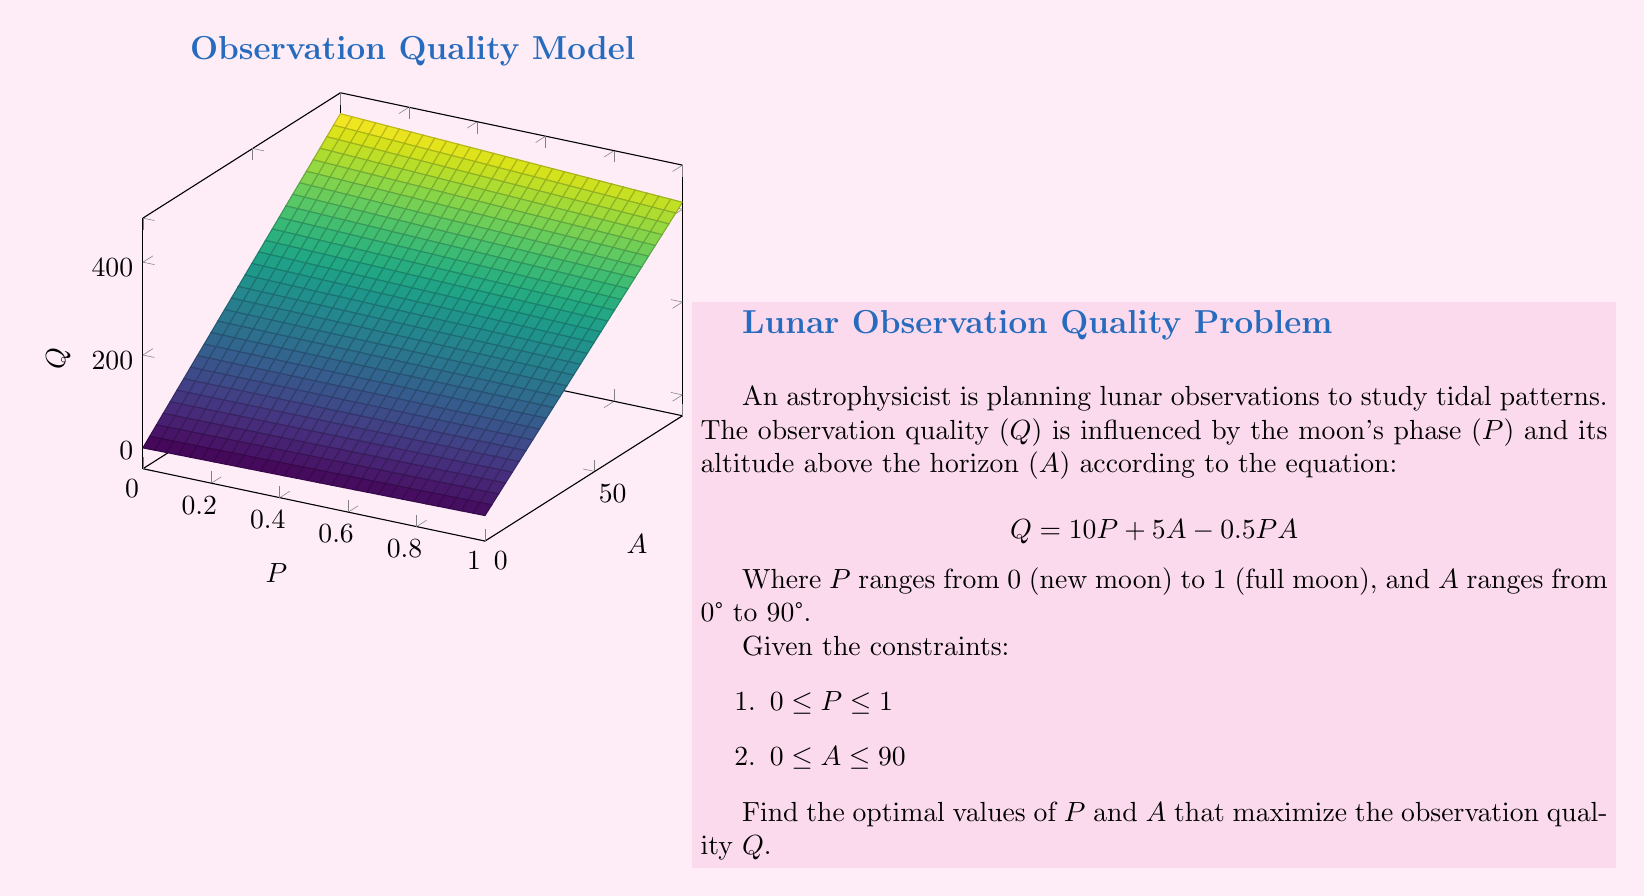Teach me how to tackle this problem. To find the optimal values of P and A that maximize Q, we need to use techniques from multivariable calculus:

1. Calculate partial derivatives:
   $\frac{\partial Q}{\partial P} = 10 - 0.5A$
   $\frac{\partial Q}{\partial A} = 5 - 0.5P$

2. Set both partial derivatives to zero:
   $10 - 0.5A = 0$
   $5 - 0.5P = 0$

3. Solve the system of equations:
   $A = 20$
   $P = 10$

4. Check the constraints:
   $0 \leq P \leq 1$ is violated by $P = 10$
   $0° \leq A \leq 90°$ is satisfied by $A = 20°$

5. Since P violates its constraint, we need to check the boundaries:
   At $P = 0$: $Q = 5A$, max at $A = 90°$, $Q = 450$
   At $P = 1$: $Q = 10 + 4.5A$, max at $A = 90°$, $Q = 415$

6. Compare with the interior point:
   At $P = 1$, $A = 20°$: $Q = 10 + 5(20) - 0.5(1)(20) = 100$

7. The global maximum occurs at the boundary:
   $P = 0$, $A = 90°$, with $Q = 450$
Answer: $P = 0$, $A = 90°$ 